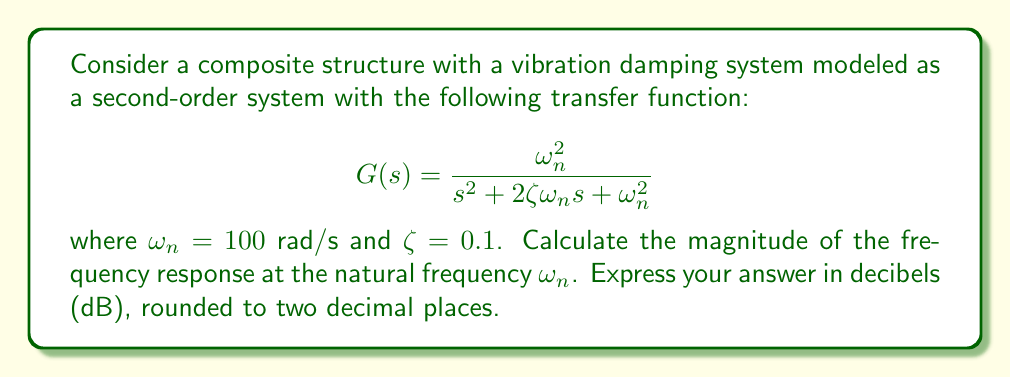Can you solve this math problem? To solve this problem, we'll follow these steps:

1) The frequency response of a system is obtained by substituting $s = j\omega$ into the transfer function, where $j$ is the imaginary unit and $\omega$ is the frequency.

2) At the natural frequency, $\omega = \omega_n = 100$ rad/s. Substituting this into the transfer function:

   $$G(j\omega_n) = \frac{\omega_n^2}{(j\omega_n)^2 + 2\zeta\omega_n(j\omega_n) + \omega_n^2}$$

3) Simplify:
   $$G(j\omega_n) = \frac{\omega_n^2}{-\omega_n^2 + 2j\zeta\omega_n^2 + \omega_n^2} = \frac{\omega_n^2}{2j\zeta\omega_n^2} = \frac{1}{2j\zeta}$$

4) The magnitude of this complex number is:
   $$|G(j\omega_n)| = \left|\frac{1}{2j\zeta}\right| = \frac{1}{2\zeta} = \frac{1}{2(0.1)} = 5$$

5) To convert to decibels, use the formula:
   $$\text{Magnitude (dB)} = 20 \log_{10}(|G(j\omega_n)|)$$

6) Substituting our value:
   $$\text{Magnitude (dB)} = 20 \log_{10}(5) \approx 13.98 \text{ dB}$$

7) Rounding to two decimal places gives 13.98 dB.
Answer: 13.98 dB 